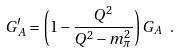<formula> <loc_0><loc_0><loc_500><loc_500>G _ { A } ^ { \prime } = \left ( 1 - \frac { Q ^ { 2 } } { Q ^ { 2 } - m _ { \pi } ^ { 2 } } \right ) G _ { A } \ .</formula> 